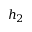<formula> <loc_0><loc_0><loc_500><loc_500>h _ { 2 }</formula> 